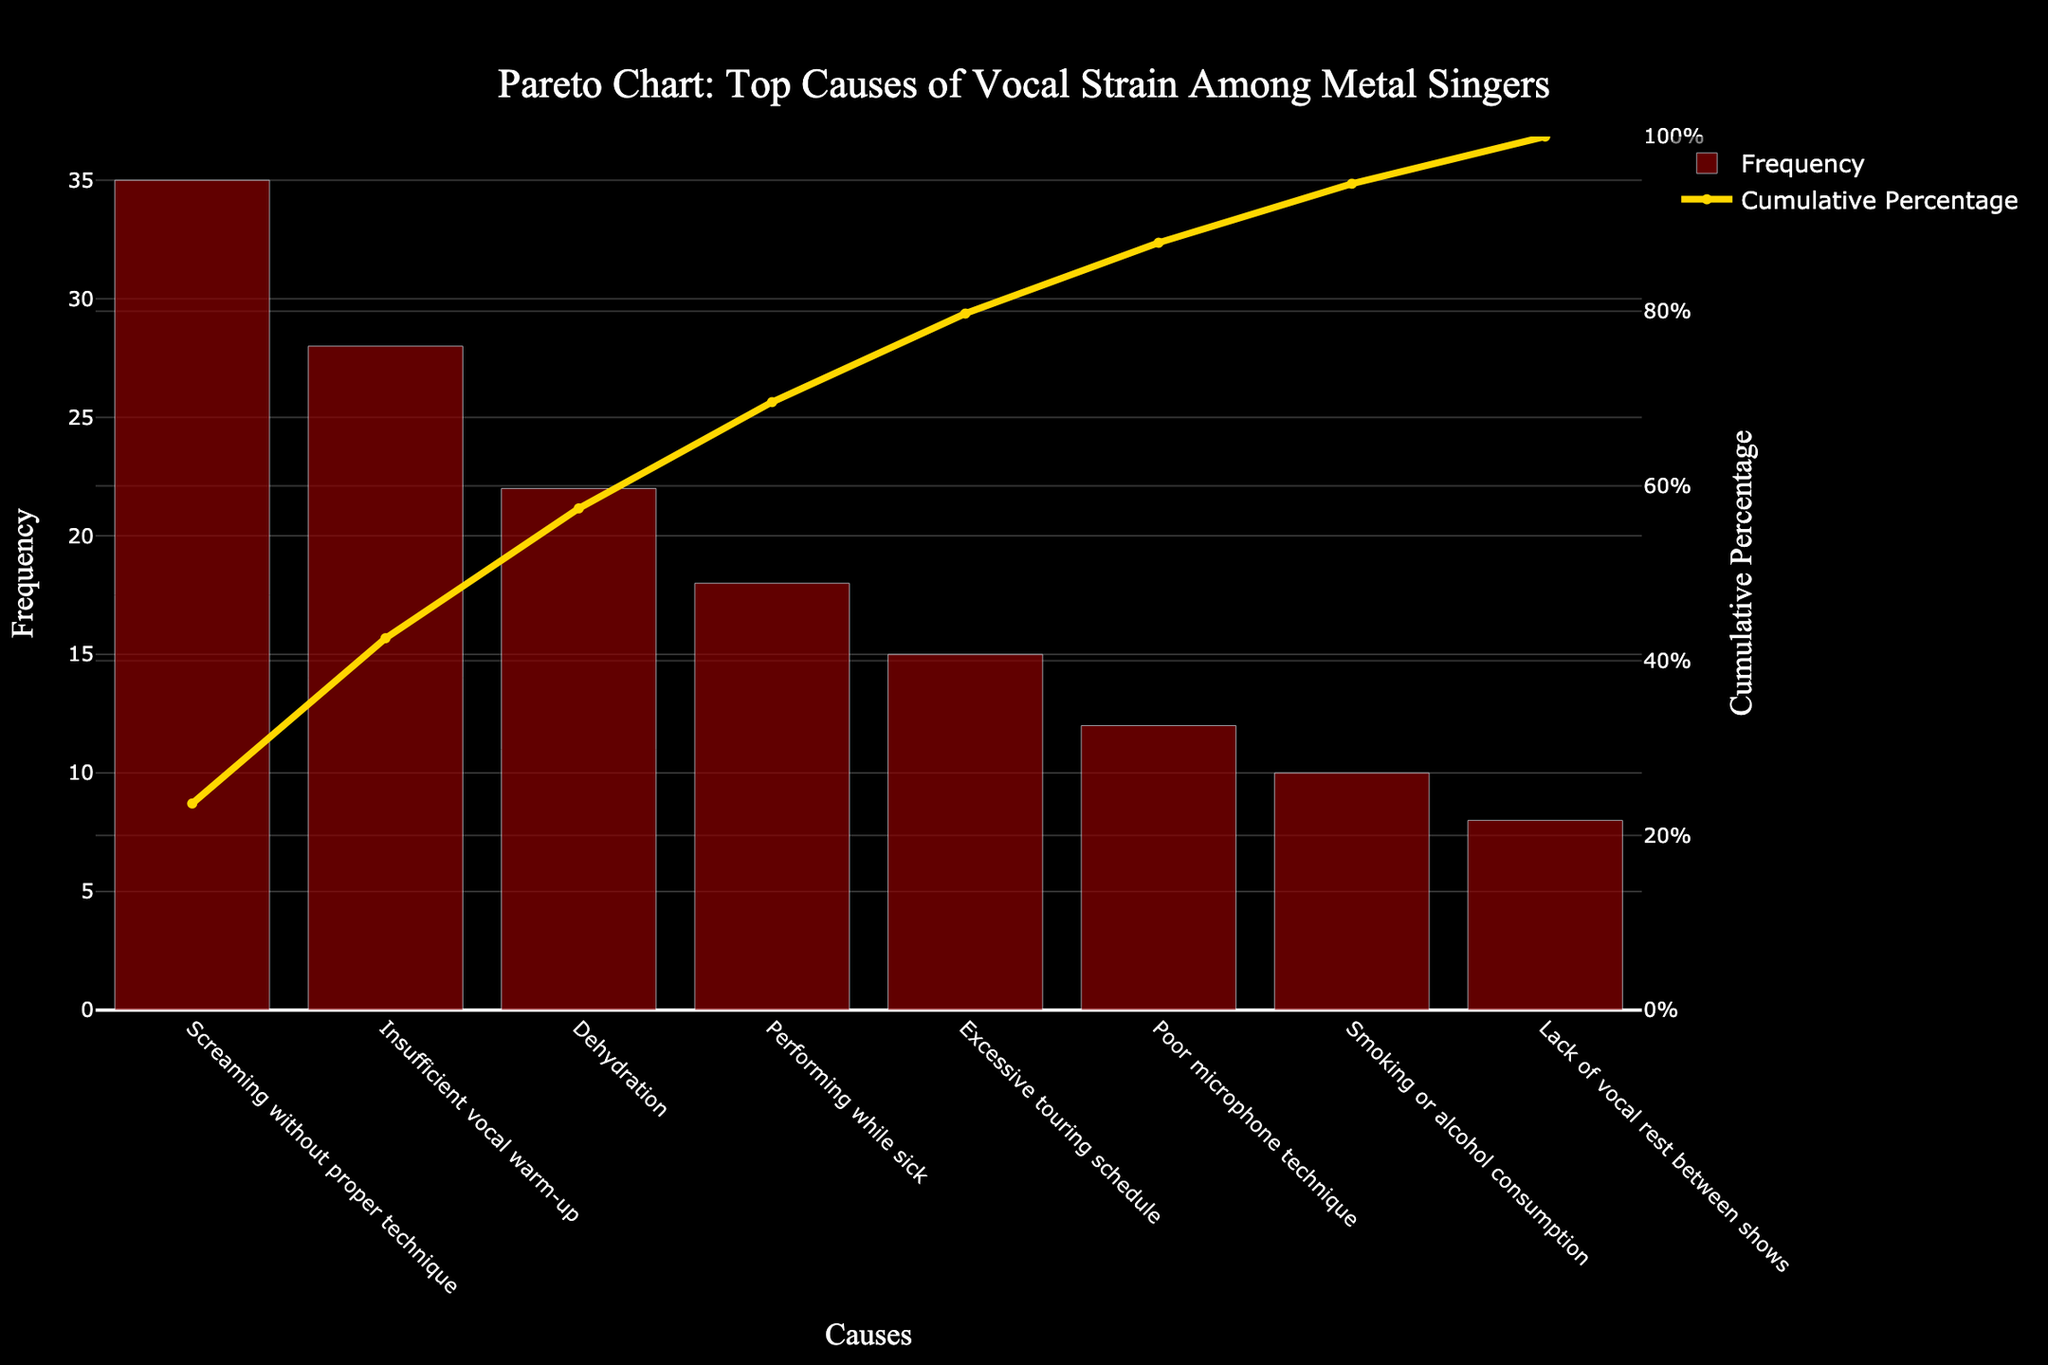What is the most common cause of vocal strain among metal singers? To find the most common cause, look at the highest bar in the chart, which represents the cause with the highest frequency.
Answer: Screaming without proper technique What percentage of vocal strain cases are caused by the top three factors? Sum the frequencies of the top three causes and divide by the total frequency, then multiply by 100. \( \text{(35 + 28 + 22)} / \text{(35 + 28 + 22 + 18 + 15 + 12 + 10 + 8)} * 100 = 85 / 148 * 100 \approx 57.43\% \)
Answer: Approximately 57.43% Which cause of vocal strain has the same cumulative percentage as its frequency percentage? Find a cause where the cumulative percentage line intersects at the same point as the bar. 'Excessive touring schedule' aligns with this as both its cumulative and frequency percentages are at 10%.
Answer: Excessive touring schedule By how much does 'Poor microphone technique' contribute more to vocal strain cases than 'Smoking or alcohol consumption'? Subtract the frequency of 'Smoking or alcohol consumption' from 'Poor microphone technique'. \( 12 - 10 = 2 \)
Answer: 2 What is the cumulative percentage of vocal strain caused by ‘Performing while sick’? Look at the figure where the cumulative percentage line intersects at the 'Performing while sick' bar.
Answer: 69.59% Which cause is ranked fourth in contributing to vocal strain cases? Identify the fourth highest bar from the left in the chart.
Answer: Performing while sick How does ‘Dehydration’ rank in terms of frequency compared to ‘Insufficient vocal warm-up’? Determine the ranks of each, where higher frequency means higher rank. ‘Insufficient vocal warm-up’ is second highest and 'Dehydration' is third highest by frequency.
Answer: Dehydration is less frequent than Insufficient vocal warm-up If we consider only the top five causes, what would be their combined frequency? Sum the frequencies of the top five causes. \( 35 + 28 + 22 + 18 + 15 = 118 \)
Answer: 118 How much more frequent is the top cause compared to the least frequent cause? Subtract the frequency of the least frequent cause from the top cause. \( 35 - 8 = 27 \)
Answer: 27 What's the cumulative percentage after considering half of the causes listed? Count half the total causes, look at their cumulative percentage line value. After four causes, cumulative percentage is around 69.59%.
Answer: 69.59% 